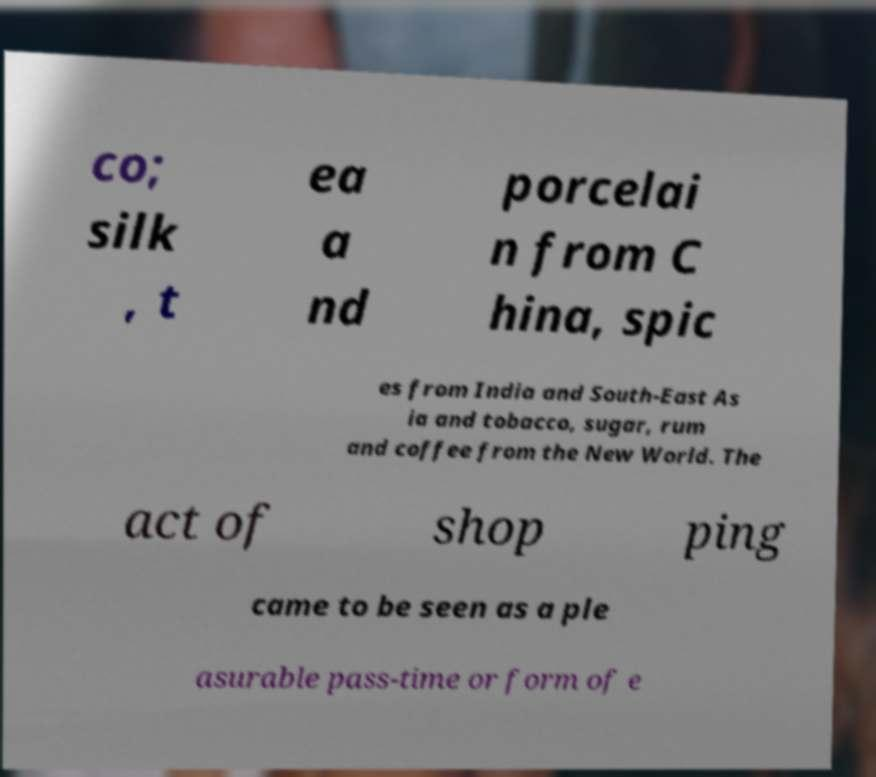Could you assist in decoding the text presented in this image and type it out clearly? co; silk , t ea a nd porcelai n from C hina, spic es from India and South-East As ia and tobacco, sugar, rum and coffee from the New World. The act of shop ping came to be seen as a ple asurable pass-time or form of e 